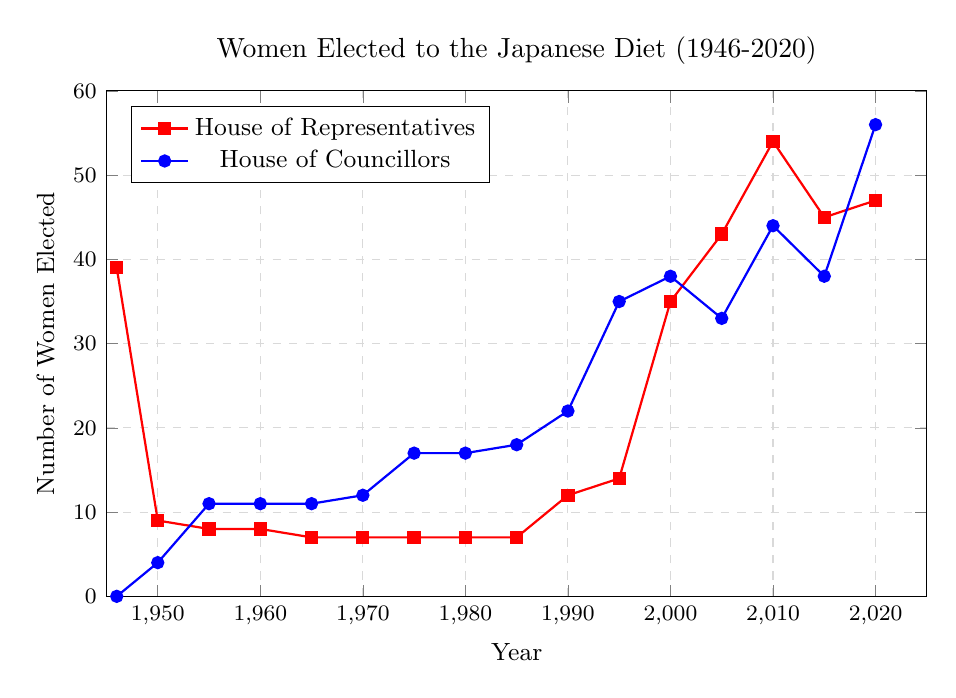What year saw the highest number of women elected to the House of Councillors? The House of Councillors series is indicated by the blue line. The highest value of this line is at the point (2020, 56).
Answer: 2020 How did the number of women elected to the House of Representatives change between 1946 and 1950? In 1946, 39 women were elected to the House of Representatives. In 1950, this number decreased to 9. The change is 39 - 9 = 30.
Answer: Decreased by 30 By how many did the number of women elected to the House of Councillors increase from 1985 to 1990? In 1985, 18 women were elected to the House of Councillors. In 1990, this number increased to 22. The increase is 22 - 18 = 4.
Answer: Increased by 4 Compare the total number of women elected to both houses in 2000. Was it greater than or less than in 2010? In 2000, the total number is 35 (House of Representatives) + 38 (House of Councillors) = 73. In 2010, it is 54 (House of Representatives) + 44 (House of Councillors) = 98. Thus, 73 < 98.
Answer: Less than Calculate the average number of women elected to the House of Representatives over the entire period. Sum the values: 39 + 9 + 8 + 8 + 7 + 7 + 7 + 7 + 7 + 12 + 14 + 35 + 43 + 54 + 45 + 47 = 353. There are 16 data points, so the average is 353 / 16 = 22.06.
Answer: 22.06 Compare the trendlines of the two houses between 2000 and 2020. How are they different? From 2000 to 2020, the House of Representatives shows a slight overall increase with some fluctuations (35 to 47). The House of Councillors shows a steady increase (38 to 56).
Answer: House of Councillors increased steadily, while the House of Representatives fluctuated Which period experienced the longest duration without a significant change in the number of women elected to the House of Representatives? From 1955 to 1985, the number remained almost constant at around 7.
Answer: 1955-1985 Does the number of women elected to the House of Councillors ever decrease from one election to the next? If so, when? Yes, between 2000 (38) and 2005 (33), there is a decrease.
Answer: 2000 to 2005 What was the combined total of women elected to both houses in 1975, and how does it compare to the total in 1980? In 1975, combined total: 7 (House of Representatives) + 17 (House of Councillors) = 24. In 1980, combined total: the same values, 24. Therefore, they are equal.
Answer: Equal 